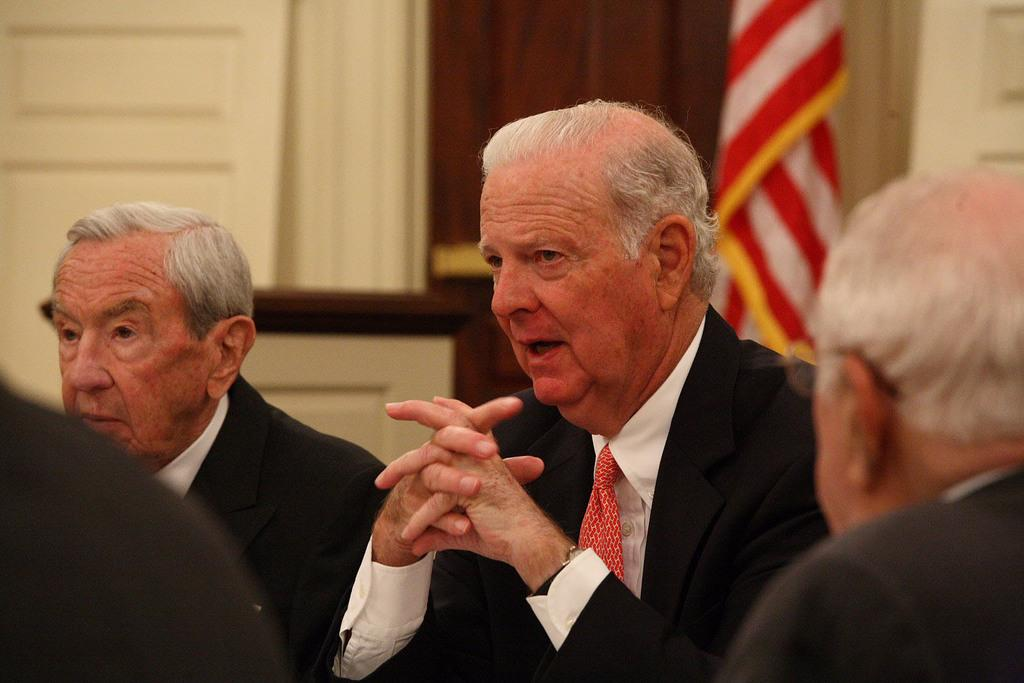What are the men in the image doing? The men in the image are sitting on chairs. What type of clothing are the men wearing? The men are wearing blazers, ties, and shirts. What can be seen in the background of the image? There is a flag and a wall in the background of the image. How many times has the history of the flag been rewritten in the image? There is no indication in the image that the history of the flag has been rewritten, nor is there any mention of the number of times it has been rewritten. 